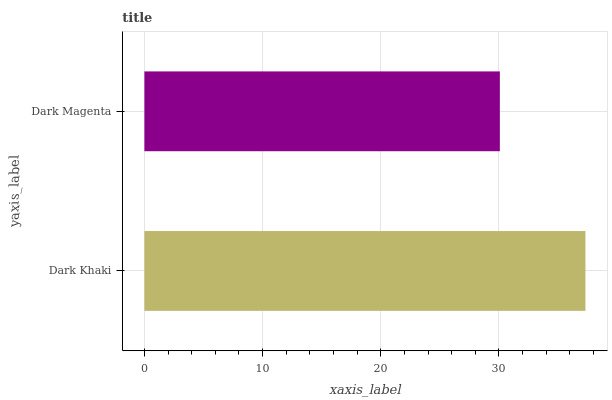Is Dark Magenta the minimum?
Answer yes or no. Yes. Is Dark Khaki the maximum?
Answer yes or no. Yes. Is Dark Magenta the maximum?
Answer yes or no. No. Is Dark Khaki greater than Dark Magenta?
Answer yes or no. Yes. Is Dark Magenta less than Dark Khaki?
Answer yes or no. Yes. Is Dark Magenta greater than Dark Khaki?
Answer yes or no. No. Is Dark Khaki less than Dark Magenta?
Answer yes or no. No. Is Dark Khaki the high median?
Answer yes or no. Yes. Is Dark Magenta the low median?
Answer yes or no. Yes. Is Dark Magenta the high median?
Answer yes or no. No. Is Dark Khaki the low median?
Answer yes or no. No. 